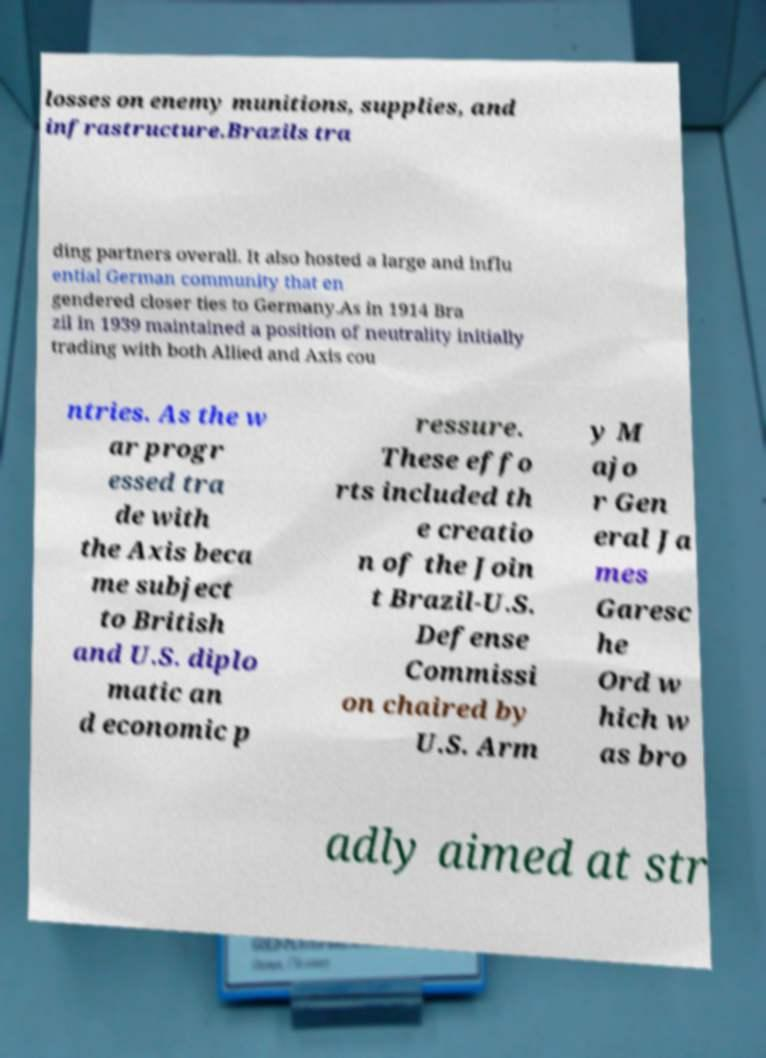There's text embedded in this image that I need extracted. Can you transcribe it verbatim? losses on enemy munitions, supplies, and infrastructure.Brazils tra ding partners overall. It also hosted a large and influ ential German community that en gendered closer ties to Germany.As in 1914 Bra zil in 1939 maintained a position of neutrality initially trading with both Allied and Axis cou ntries. As the w ar progr essed tra de with the Axis beca me subject to British and U.S. diplo matic an d economic p ressure. These effo rts included th e creatio n of the Join t Brazil-U.S. Defense Commissi on chaired by U.S. Arm y M ajo r Gen eral Ja mes Garesc he Ord w hich w as bro adly aimed at str 